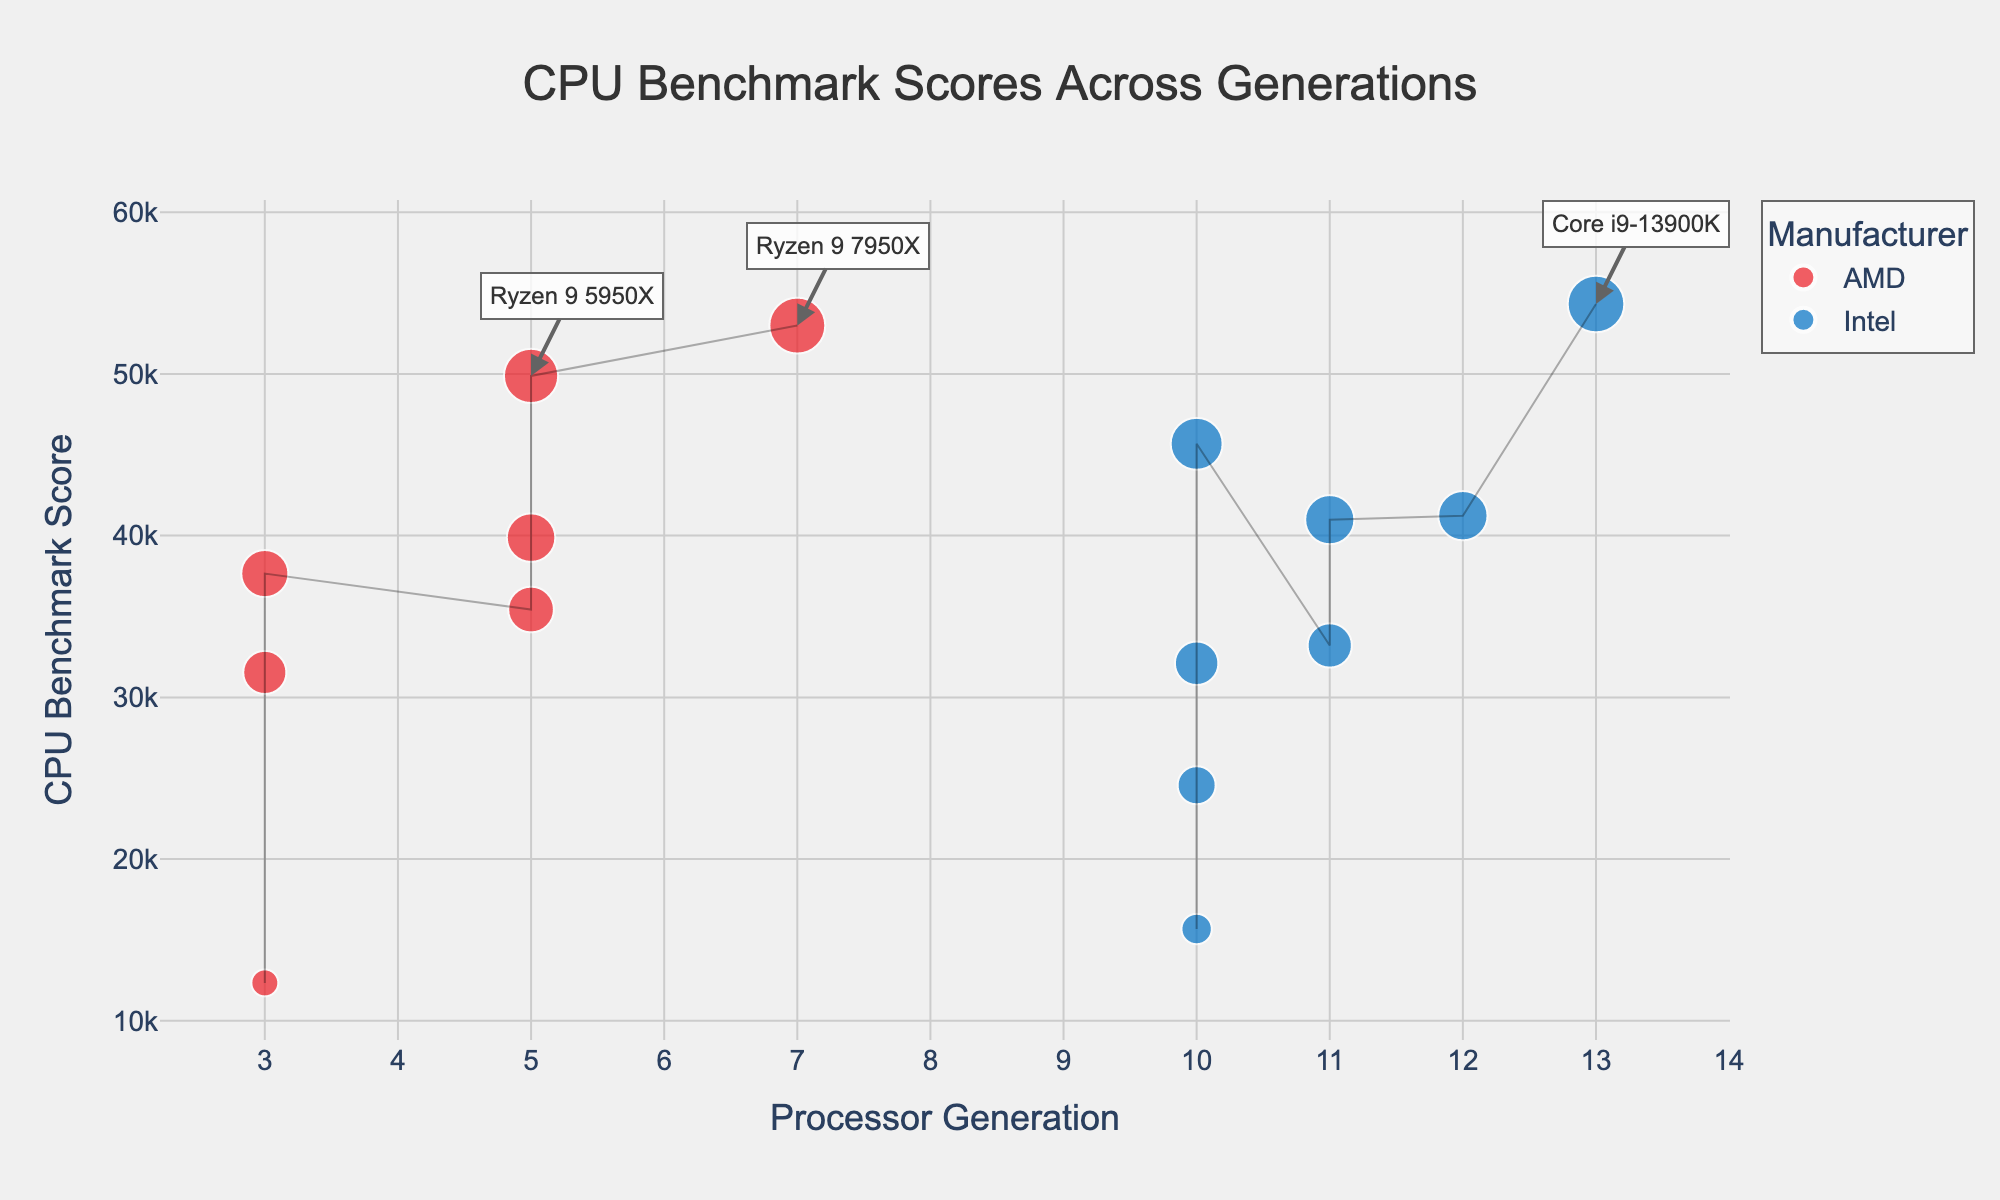What are the manufacturers represented in the plot? The plot uses colors to distinguish between processors from different manufacturers. The legend indicates two manufacturers: Intel and AMD.
Answer: Intel, AMD Which processor has the highest benchmark score? The plot has an annotation for the top processors. The highest benchmark score is annotated, and it belongs to the processor Core i9-13900K.
Answer: Core i9-13900K How many processors are represented for Generation 10? By examining the x-axis labeled 'Processor Generation' and checking the processors plotted at Generation 10, we can count five processors in this generation.
Answer: 5 What is the median benchmark score for AMD processors? To find the median, we need to sort the AMD processor scores and find the middle value. The scores for AMD processors are 12345, 31543, 35432, 37654, 39876, 49876, 52987. The median value is the one in the middle: 37654.
Answer: 37654 Which generation has Intel processors with the least and most benchmark scores? By inspecting the points labeled for Intel processors across the x-axis:
- The least score is the Intel Pentium Gold G6400 in Generation 10.
- The highest score is the Intel Core i9-13900K in Generation 13.
Answer: Generation 10 and 13 Compare the benchmark scores between Intel Core i9-10900K and AMD Ryzen 9 5950X; which one is higher? The plot shows that Intel Core i9-10900K has a score of 45678, while AMD Ryzen 9 5950X has a score of 49876. Comparing these, the AMD Ryzen 9 5950X has a higher benchmark score.
Answer: Ryzen 9 5950X What is the average benchmark score for Generation 5 processors? We calculate the average of the scores for Generation 5 processors. The scores are 39876, 49876, and 35432.
Sum = 39876 + 49876 + 35432 = 125184
Average = 125184 / 3 = 41728
Answer: 41728 What are the benchmark scores for processors in Generation 11? For Generation 11, the processors are i5-11600K with 33210 and i7-11700K with 40987. So the respective scores are 33210 and 40987.
Answer: 33210, 40987 Which processor from AMD has the least benchmark score, and what is the value? From the plot, the lowest scoring AMD processor is Athlon 3000G as shown by its position on the y-axis, and the score is 12345.
Answer: Athlon 3000G, 12345 